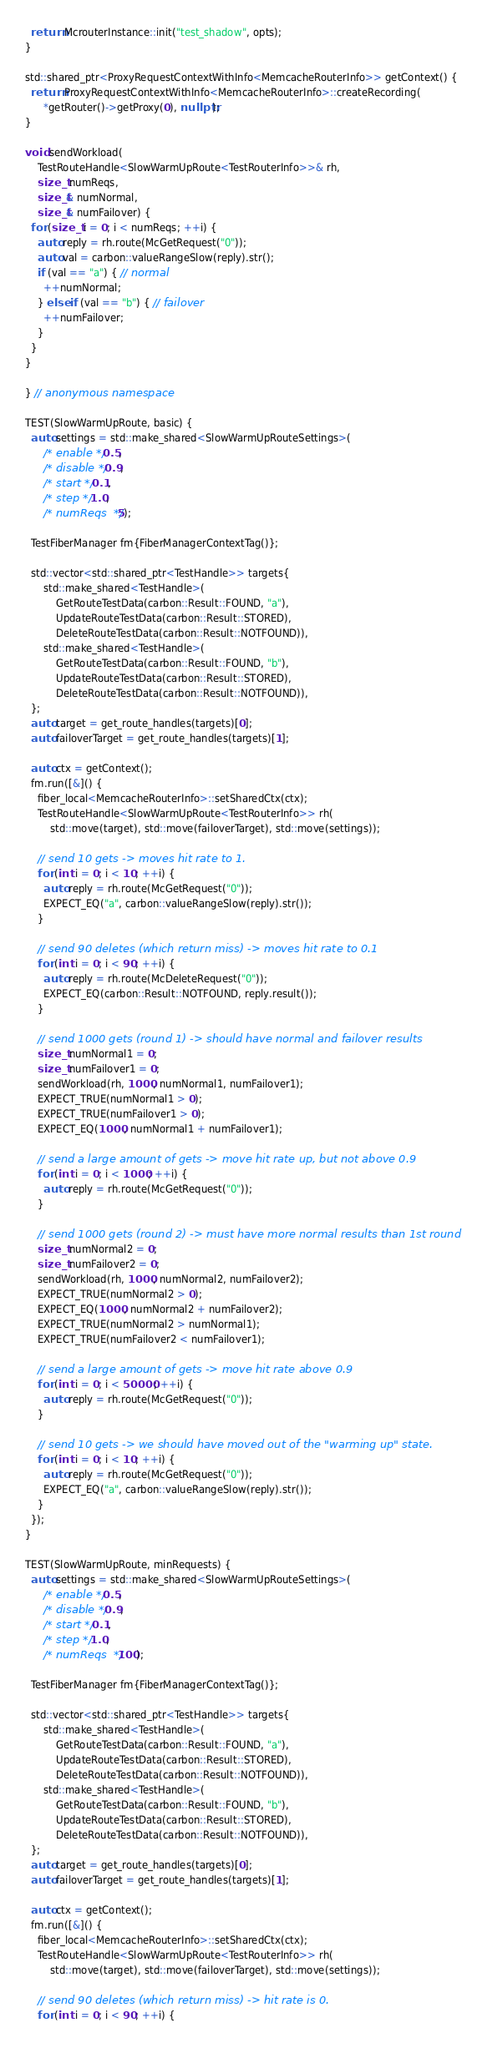Convert code to text. <code><loc_0><loc_0><loc_500><loc_500><_C++_>  return McrouterInstance::init("test_shadow", opts);
}

std::shared_ptr<ProxyRequestContextWithInfo<MemcacheRouterInfo>> getContext() {
  return ProxyRequestContextWithInfo<MemcacheRouterInfo>::createRecording(
      *getRouter()->getProxy(0), nullptr);
}

void sendWorkload(
    TestRouteHandle<SlowWarmUpRoute<TestRouterInfo>>& rh,
    size_t numReqs,
    size_t& numNormal,
    size_t& numFailover) {
  for (size_t i = 0; i < numReqs; ++i) {
    auto reply = rh.route(McGetRequest("0"));
    auto val = carbon::valueRangeSlow(reply).str();
    if (val == "a") { // normal
      ++numNormal;
    } else if (val == "b") { // failover
      ++numFailover;
    }
  }
}

} // anonymous namespace

TEST(SlowWarmUpRoute, basic) {
  auto settings = std::make_shared<SlowWarmUpRouteSettings>(
      /* enable */ 0.5,
      /* disable */ 0.9,
      /* start */ 0.1,
      /* step */ 1.0,
      /* numReqs  */ 5);

  TestFiberManager fm{FiberManagerContextTag()};

  std::vector<std::shared_ptr<TestHandle>> targets{
      std::make_shared<TestHandle>(
          GetRouteTestData(carbon::Result::FOUND, "a"),
          UpdateRouteTestData(carbon::Result::STORED),
          DeleteRouteTestData(carbon::Result::NOTFOUND)),
      std::make_shared<TestHandle>(
          GetRouteTestData(carbon::Result::FOUND, "b"),
          UpdateRouteTestData(carbon::Result::STORED),
          DeleteRouteTestData(carbon::Result::NOTFOUND)),
  };
  auto target = get_route_handles(targets)[0];
  auto failoverTarget = get_route_handles(targets)[1];

  auto ctx = getContext();
  fm.run([&]() {
    fiber_local<MemcacheRouterInfo>::setSharedCtx(ctx);
    TestRouteHandle<SlowWarmUpRoute<TestRouterInfo>> rh(
        std::move(target), std::move(failoverTarget), std::move(settings));

    // send 10 gets -> moves hit rate to 1.
    for (int i = 0; i < 10; ++i) {
      auto reply = rh.route(McGetRequest("0"));
      EXPECT_EQ("a", carbon::valueRangeSlow(reply).str());
    }

    // send 90 deletes (which return miss) -> moves hit rate to 0.1
    for (int i = 0; i < 90; ++i) {
      auto reply = rh.route(McDeleteRequest("0"));
      EXPECT_EQ(carbon::Result::NOTFOUND, reply.result());
    }

    // send 1000 gets (round 1) -> should have normal and failover results
    size_t numNormal1 = 0;
    size_t numFailover1 = 0;
    sendWorkload(rh, 1000, numNormal1, numFailover1);
    EXPECT_TRUE(numNormal1 > 0);
    EXPECT_TRUE(numFailover1 > 0);
    EXPECT_EQ(1000, numNormal1 + numFailover1);

    // send a large amount of gets -> move hit rate up, but not above 0.9
    for (int i = 0; i < 1000; ++i) {
      auto reply = rh.route(McGetRequest("0"));
    }

    // send 1000 gets (round 2) -> must have more normal results than 1st round
    size_t numNormal2 = 0;
    size_t numFailover2 = 0;
    sendWorkload(rh, 1000, numNormal2, numFailover2);
    EXPECT_TRUE(numNormal2 > 0);
    EXPECT_EQ(1000, numNormal2 + numFailover2);
    EXPECT_TRUE(numNormal2 > numNormal1);
    EXPECT_TRUE(numFailover2 < numFailover1);

    // send a large amount of gets -> move hit rate above 0.9
    for (int i = 0; i < 50000; ++i) {
      auto reply = rh.route(McGetRequest("0"));
    }

    // send 10 gets -> we should have moved out of the "warming up" state.
    for (int i = 0; i < 10; ++i) {
      auto reply = rh.route(McGetRequest("0"));
      EXPECT_EQ("a", carbon::valueRangeSlow(reply).str());
    }
  });
}

TEST(SlowWarmUpRoute, minRequests) {
  auto settings = std::make_shared<SlowWarmUpRouteSettings>(
      /* enable */ 0.5,
      /* disable */ 0.9,
      /* start */ 0.1,
      /* step */ 1.0,
      /* numReqs  */ 100);

  TestFiberManager fm{FiberManagerContextTag()};

  std::vector<std::shared_ptr<TestHandle>> targets{
      std::make_shared<TestHandle>(
          GetRouteTestData(carbon::Result::FOUND, "a"),
          UpdateRouteTestData(carbon::Result::STORED),
          DeleteRouteTestData(carbon::Result::NOTFOUND)),
      std::make_shared<TestHandle>(
          GetRouteTestData(carbon::Result::FOUND, "b"),
          UpdateRouteTestData(carbon::Result::STORED),
          DeleteRouteTestData(carbon::Result::NOTFOUND)),
  };
  auto target = get_route_handles(targets)[0];
  auto failoverTarget = get_route_handles(targets)[1];

  auto ctx = getContext();
  fm.run([&]() {
    fiber_local<MemcacheRouterInfo>::setSharedCtx(ctx);
    TestRouteHandle<SlowWarmUpRoute<TestRouterInfo>> rh(
        std::move(target), std::move(failoverTarget), std::move(settings));

    // send 90 deletes (which return miss) -> hit rate is 0.
    for (int i = 0; i < 90; ++i) {</code> 